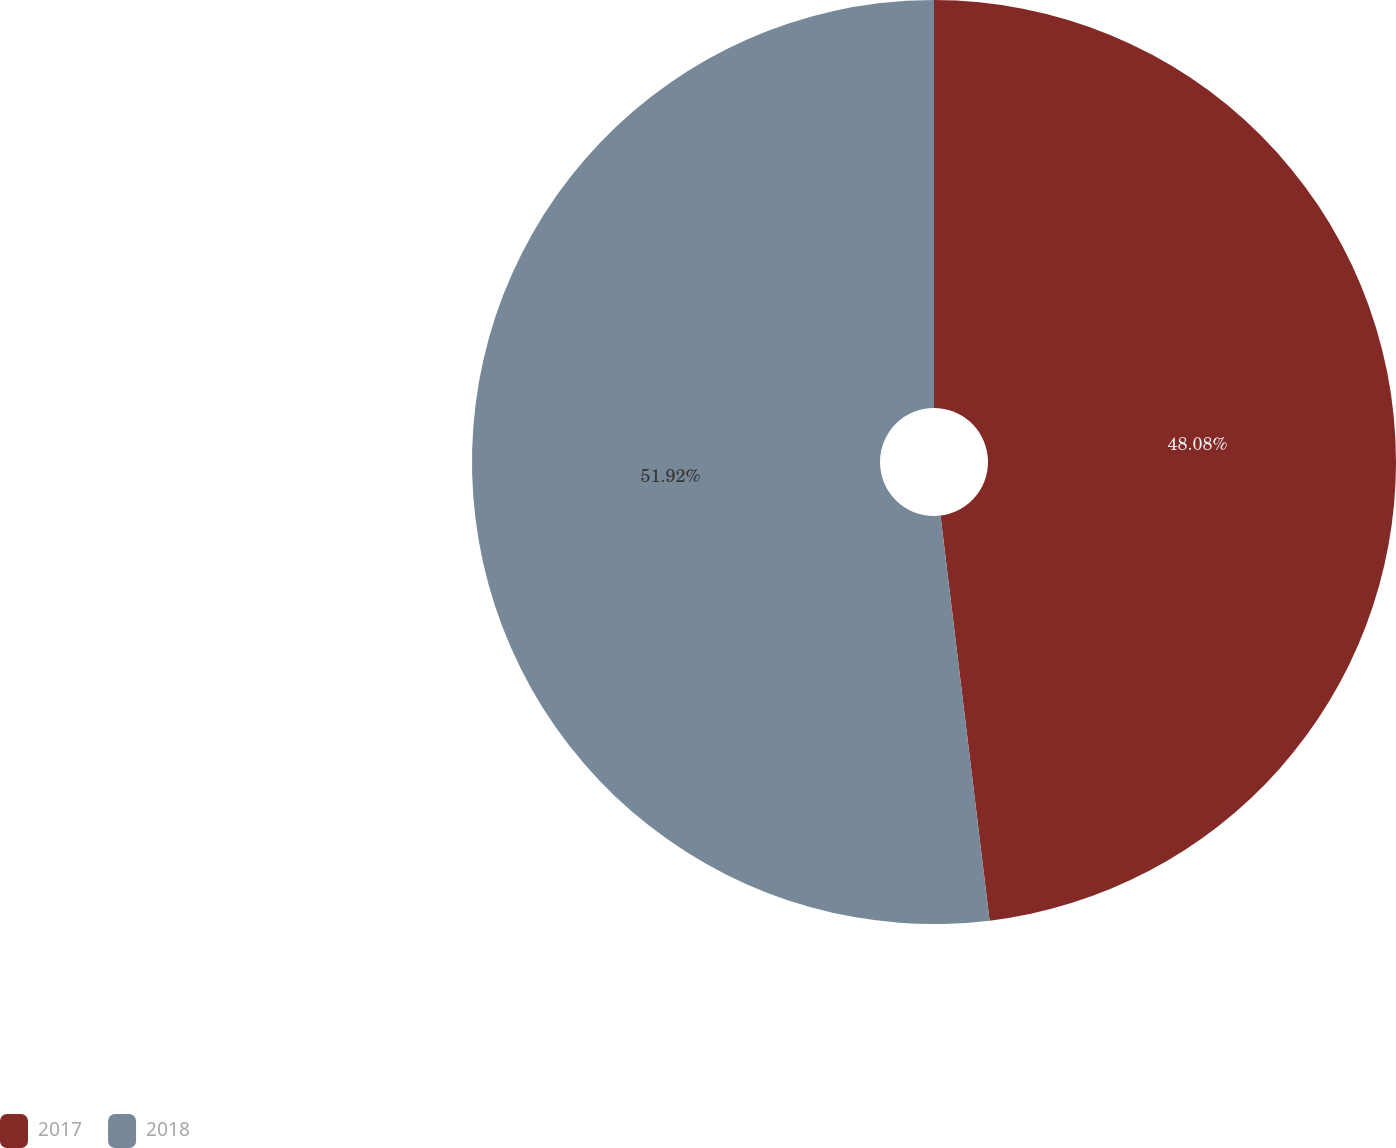Convert chart to OTSL. <chart><loc_0><loc_0><loc_500><loc_500><pie_chart><fcel>2017<fcel>2018<nl><fcel>48.08%<fcel>51.92%<nl></chart> 